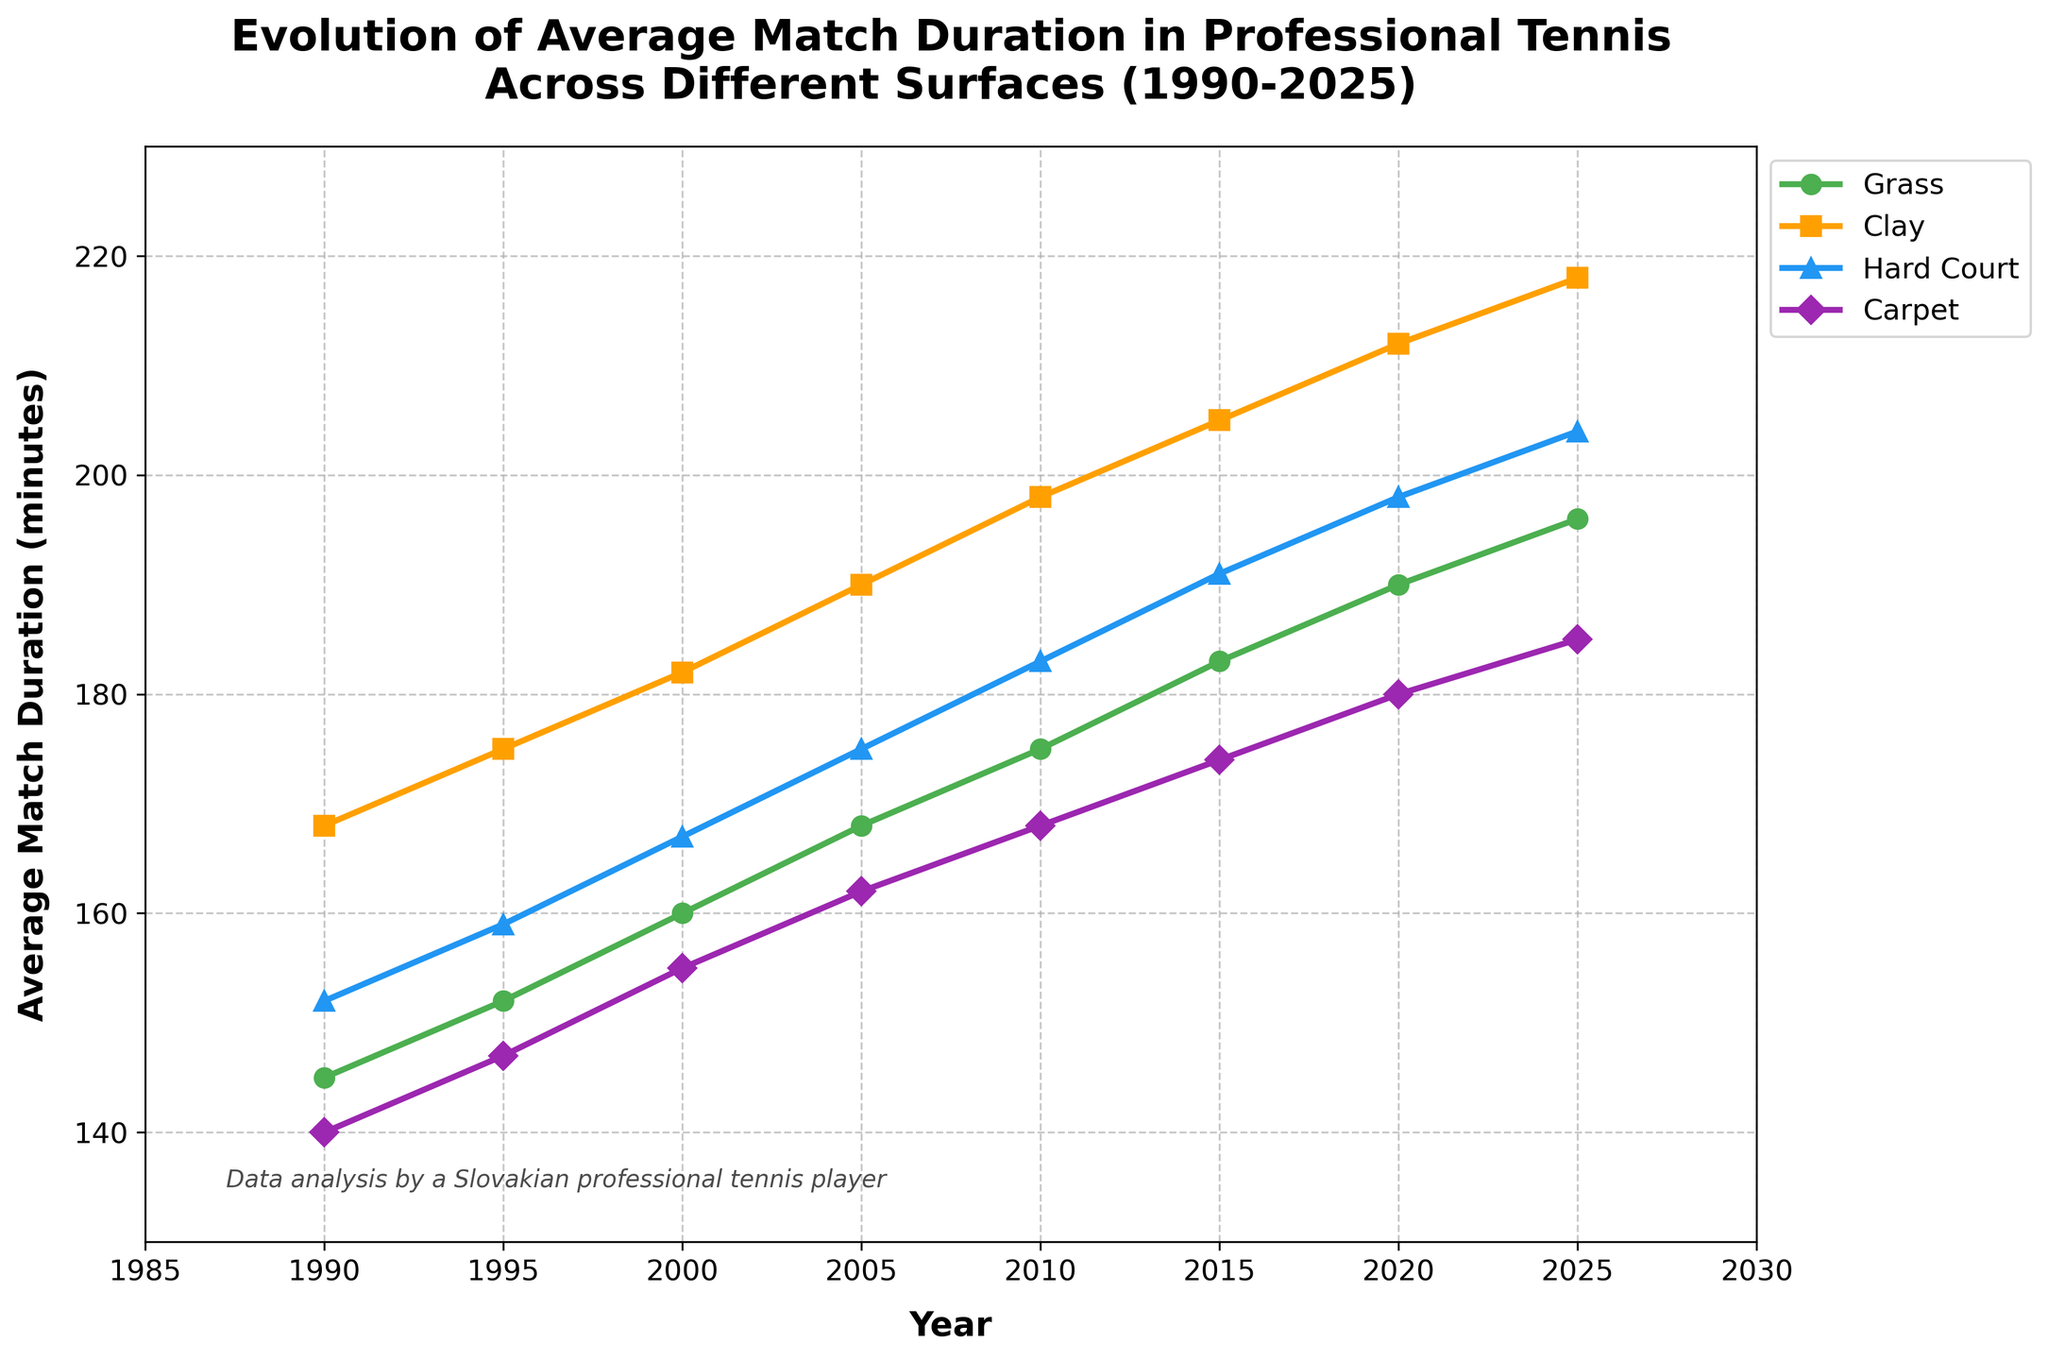What's the period during which the average match duration on Clay surfaces increased the most? To determine the period with the highest increase in average match duration on Clay surfaces, we check the differences between the values for each consecutive period: 1995-1990 (175-168=7), 2000-1995 (182-175=7), 2005-2000 (190-182=8), 2010-2005 (198-190=8), 2015-2010 (205-198=7), 2020-2015 (212-205=7), 2025-2020 (218-212=6). The increases of 8 minutes occurred from 2000 to 2005 and 2005 to 2010, making these the periods with the highest increase.
Answer: 2000-2005 and 2005-2010 Which surface had the least increase in average match duration from 1990 to 2025? To identify which surface had the least increase, we calculate the total increase for each surface: Grass (196-145=51), Clay (218-168=50), Hard Court (204-152=52), Carpet (185-140=45). Hence, Carpet had the least increase in average match duration over this period, with a total increase of 45 minutes.
Answer: Carpet By how many minutes did the average match duration on Hard Courts increase between 2000 and 2010? We find the increase by subtracting the 2000 value from the 2010 value for Hard Courts. The values are 167 (2000) and 183 (2010), so the difference is 183 - 167 = 16 minutes.
Answer: 16 minutes What was the average match duration in 2025 across all surfaces? To find the average for 2025, add the durations for all surfaces and divide by the number of surfaces: (196 + 218 + 204 + 185) / 4 = 803 / 4 = 200.75 minutes.
Answer: 200.75 minutes How did the average match duration on Grass compare to that on Hard Courts in 2015? Check the values for Grass and Hard Courts in 2015. Grass had 183 minutes and Hard Courts had 191 minutes. Comparing these, Hard Courts are longer by 191 - 183 = 8 minutes.
Answer: Hard Courts is 8 minutes longer Which surface shows the most consistent (least variable) increase in average match duration from 1990 to 2025? To determine this, we observe the increases between each period for all surfaces and identify which has the most consistent changes. Grass: 7, 8, 8, 7, 7, 6; Clay: 7, 7, 8, 8, 7, 7, 6; Hard Court: 7, 8, 8, 8, 7, 6; Carpet: 7, 7, 7, 7, 6, 5. Carpet has the least variability in its increments, rendering it the most consistent.
Answer: Carpet Which surface had the highest average match duration in 2020? Review the values for 2020: Grass (190), Clay (212), Hard Court (198), Carpet (180). The surface with the maximum value is Clay with 212 minutes.
Answer: Clay Between 2010 and 2020, which surface had the highest increase in average match duration? The increases for each surface from 2010 to 2020 are: Grass (190-175=15), Clay (212-198=14), Hard Court (198-183=15), Carpet (180-168=12). The highest increase is for both Grass and Hard Court, at 15 minutes each.
Answer: Grass and Hard Court 